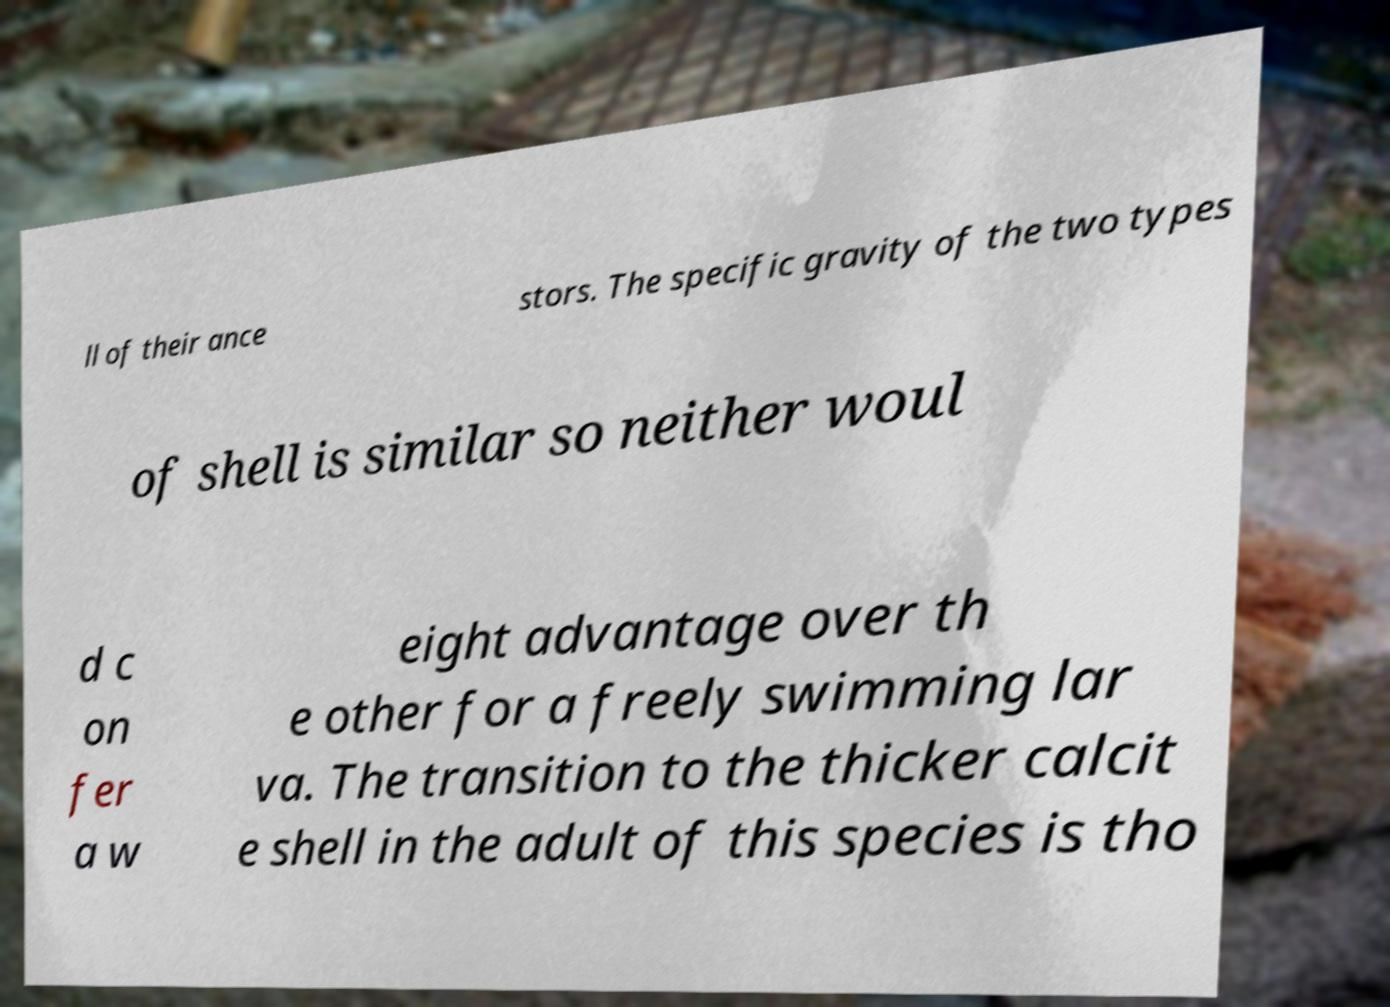Could you extract and type out the text from this image? ll of their ance stors. The specific gravity of the two types of shell is similar so neither woul d c on fer a w eight advantage over th e other for a freely swimming lar va. The transition to the thicker calcit e shell in the adult of this species is tho 